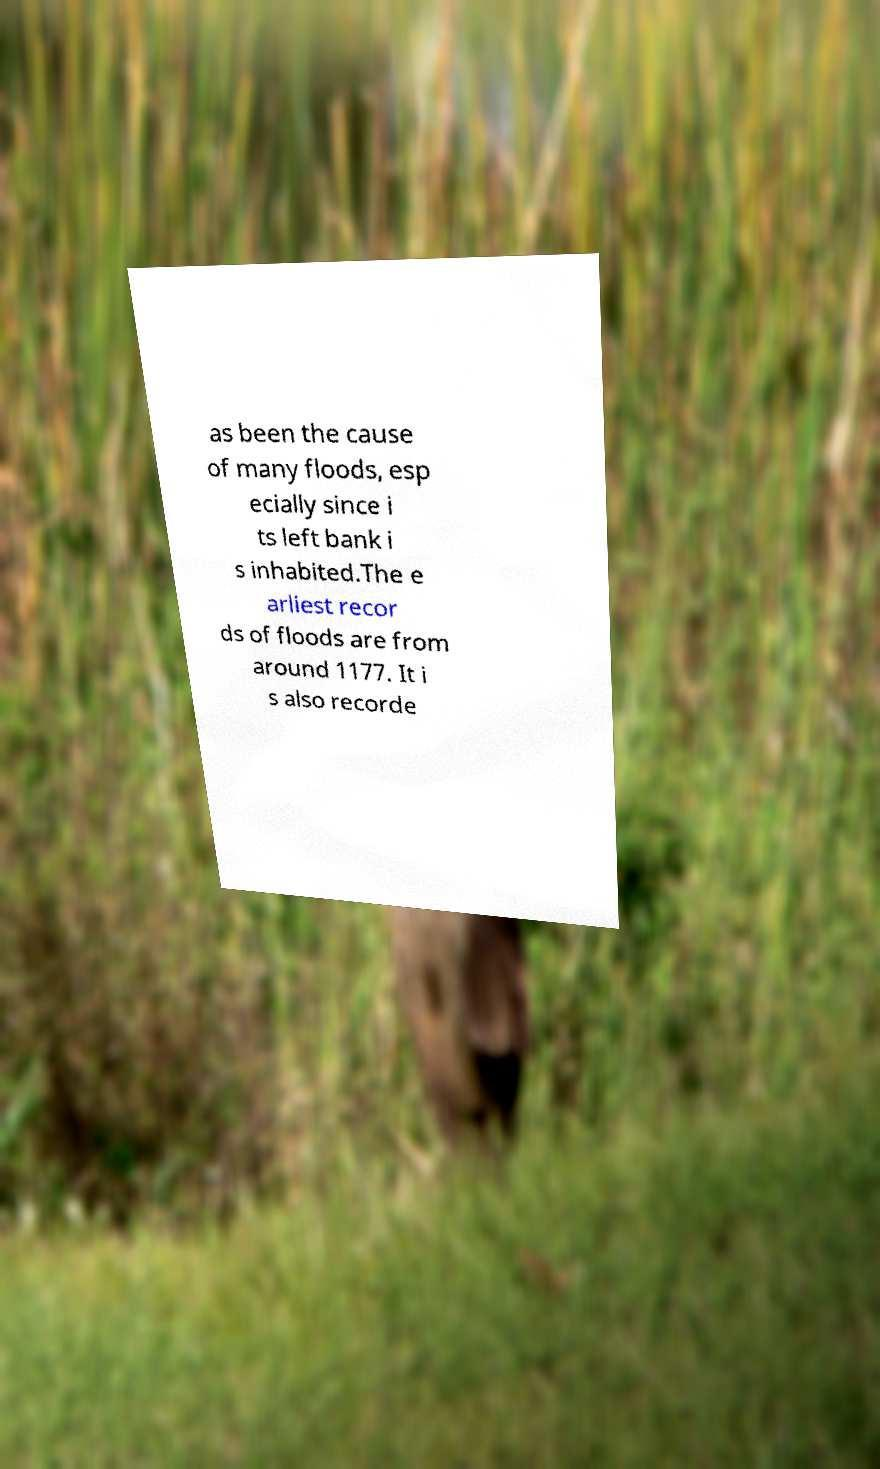For documentation purposes, I need the text within this image transcribed. Could you provide that? as been the cause of many floods, esp ecially since i ts left bank i s inhabited.The e arliest recor ds of floods are from around 1177. It i s also recorde 